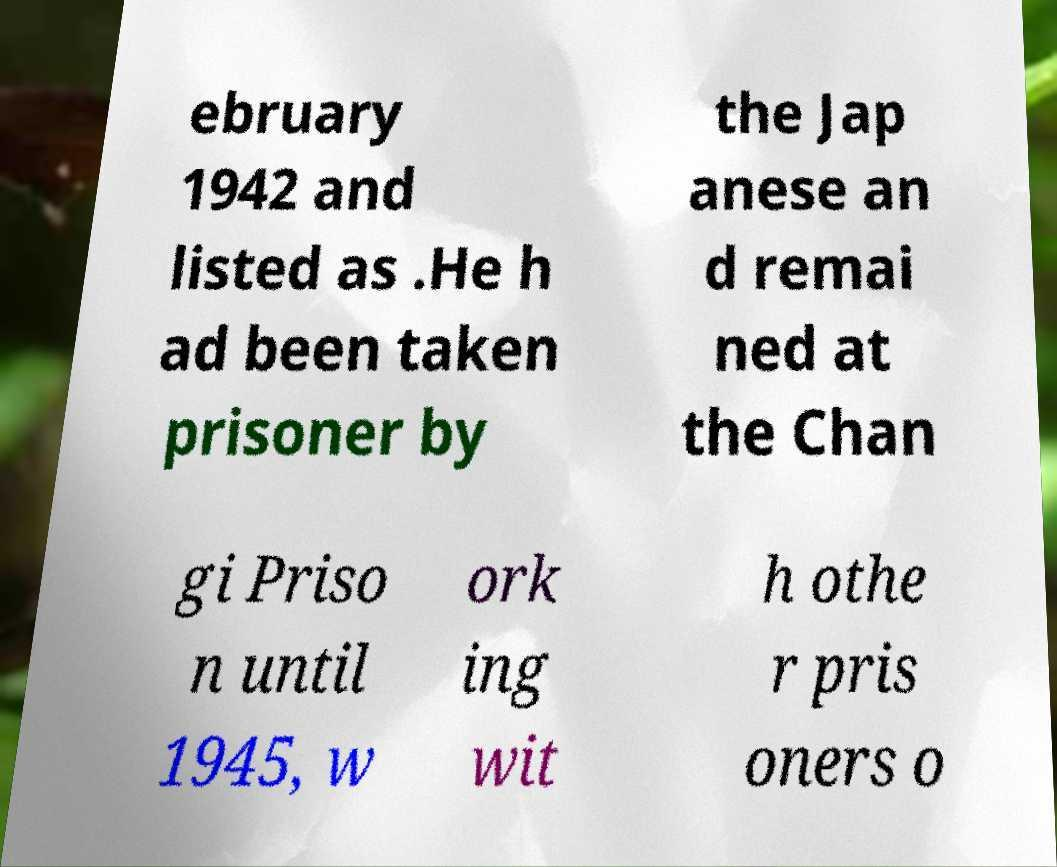I need the written content from this picture converted into text. Can you do that? ebruary 1942 and listed as .He h ad been taken prisoner by the Jap anese an d remai ned at the Chan gi Priso n until 1945, w ork ing wit h othe r pris oners o 